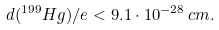<formula> <loc_0><loc_0><loc_500><loc_500>d ( ^ { 1 9 9 } H g ) / e < 9 . 1 \cdot 1 0 ^ { - 2 8 } \, c m .</formula> 